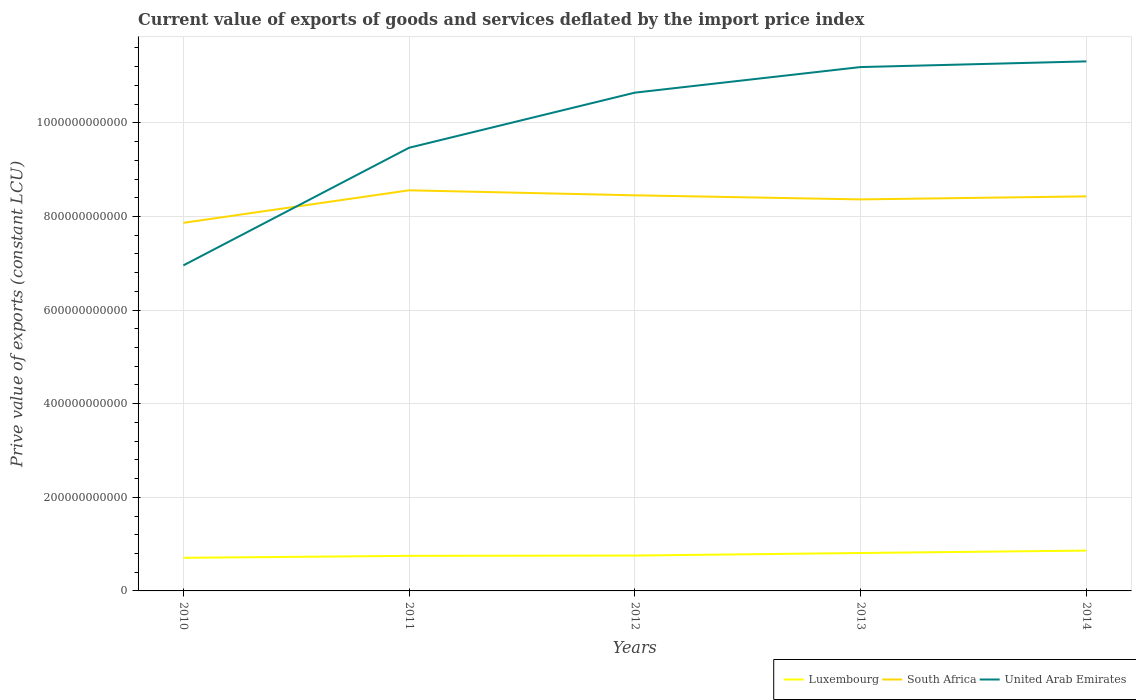How many different coloured lines are there?
Give a very brief answer. 3. Across all years, what is the maximum prive value of exports in United Arab Emirates?
Offer a terse response. 6.95e+11. In which year was the prive value of exports in Luxembourg maximum?
Keep it short and to the point. 2010. What is the total prive value of exports in Luxembourg in the graph?
Offer a very short reply. -4.20e+09. What is the difference between the highest and the second highest prive value of exports in Luxembourg?
Offer a very short reply. 1.54e+1. What is the difference between the highest and the lowest prive value of exports in South Africa?
Keep it short and to the point. 4. Is the prive value of exports in United Arab Emirates strictly greater than the prive value of exports in South Africa over the years?
Give a very brief answer. No. How many lines are there?
Your answer should be compact. 3. How many years are there in the graph?
Give a very brief answer. 5. What is the difference between two consecutive major ticks on the Y-axis?
Offer a terse response. 2.00e+11. Are the values on the major ticks of Y-axis written in scientific E-notation?
Give a very brief answer. No. Where does the legend appear in the graph?
Your response must be concise. Bottom right. How many legend labels are there?
Provide a succinct answer. 3. How are the legend labels stacked?
Ensure brevity in your answer.  Horizontal. What is the title of the graph?
Provide a short and direct response. Current value of exports of goods and services deflated by the import price index. Does "Paraguay" appear as one of the legend labels in the graph?
Your answer should be very brief. No. What is the label or title of the X-axis?
Offer a very short reply. Years. What is the label or title of the Y-axis?
Your answer should be very brief. Prive value of exports (constant LCU). What is the Prive value of exports (constant LCU) of Luxembourg in 2010?
Ensure brevity in your answer.  7.08e+1. What is the Prive value of exports (constant LCU) of South Africa in 2010?
Keep it short and to the point. 7.86e+11. What is the Prive value of exports (constant LCU) in United Arab Emirates in 2010?
Make the answer very short. 6.95e+11. What is the Prive value of exports (constant LCU) of Luxembourg in 2011?
Give a very brief answer. 7.50e+1. What is the Prive value of exports (constant LCU) in South Africa in 2011?
Your response must be concise. 8.56e+11. What is the Prive value of exports (constant LCU) in United Arab Emirates in 2011?
Make the answer very short. 9.47e+11. What is the Prive value of exports (constant LCU) of Luxembourg in 2012?
Ensure brevity in your answer.  7.56e+1. What is the Prive value of exports (constant LCU) in South Africa in 2012?
Make the answer very short. 8.45e+11. What is the Prive value of exports (constant LCU) in United Arab Emirates in 2012?
Your response must be concise. 1.06e+12. What is the Prive value of exports (constant LCU) of Luxembourg in 2013?
Your answer should be very brief. 8.10e+1. What is the Prive value of exports (constant LCU) of South Africa in 2013?
Keep it short and to the point. 8.36e+11. What is the Prive value of exports (constant LCU) in United Arab Emirates in 2013?
Your response must be concise. 1.12e+12. What is the Prive value of exports (constant LCU) of Luxembourg in 2014?
Your answer should be compact. 8.62e+1. What is the Prive value of exports (constant LCU) of South Africa in 2014?
Provide a succinct answer. 8.43e+11. What is the Prive value of exports (constant LCU) of United Arab Emirates in 2014?
Your response must be concise. 1.13e+12. Across all years, what is the maximum Prive value of exports (constant LCU) of Luxembourg?
Your response must be concise. 8.62e+1. Across all years, what is the maximum Prive value of exports (constant LCU) in South Africa?
Your answer should be compact. 8.56e+11. Across all years, what is the maximum Prive value of exports (constant LCU) in United Arab Emirates?
Provide a succinct answer. 1.13e+12. Across all years, what is the minimum Prive value of exports (constant LCU) of Luxembourg?
Provide a short and direct response. 7.08e+1. Across all years, what is the minimum Prive value of exports (constant LCU) of South Africa?
Provide a succinct answer. 7.86e+11. Across all years, what is the minimum Prive value of exports (constant LCU) in United Arab Emirates?
Give a very brief answer. 6.95e+11. What is the total Prive value of exports (constant LCU) in Luxembourg in the graph?
Give a very brief answer. 3.88e+11. What is the total Prive value of exports (constant LCU) of South Africa in the graph?
Your answer should be compact. 4.17e+12. What is the total Prive value of exports (constant LCU) of United Arab Emirates in the graph?
Ensure brevity in your answer.  4.96e+12. What is the difference between the Prive value of exports (constant LCU) in Luxembourg in 2010 and that in 2011?
Offer a terse response. -4.20e+09. What is the difference between the Prive value of exports (constant LCU) of South Africa in 2010 and that in 2011?
Offer a very short reply. -6.95e+1. What is the difference between the Prive value of exports (constant LCU) in United Arab Emirates in 2010 and that in 2011?
Keep it short and to the point. -2.51e+11. What is the difference between the Prive value of exports (constant LCU) of Luxembourg in 2010 and that in 2012?
Your response must be concise. -4.81e+09. What is the difference between the Prive value of exports (constant LCU) of South Africa in 2010 and that in 2012?
Your answer should be compact. -5.88e+1. What is the difference between the Prive value of exports (constant LCU) of United Arab Emirates in 2010 and that in 2012?
Ensure brevity in your answer.  -3.69e+11. What is the difference between the Prive value of exports (constant LCU) in Luxembourg in 2010 and that in 2013?
Offer a terse response. -1.02e+1. What is the difference between the Prive value of exports (constant LCU) of South Africa in 2010 and that in 2013?
Your answer should be compact. -5.01e+1. What is the difference between the Prive value of exports (constant LCU) of United Arab Emirates in 2010 and that in 2013?
Offer a terse response. -4.24e+11. What is the difference between the Prive value of exports (constant LCU) in Luxembourg in 2010 and that in 2014?
Offer a very short reply. -1.54e+1. What is the difference between the Prive value of exports (constant LCU) of South Africa in 2010 and that in 2014?
Ensure brevity in your answer.  -5.66e+1. What is the difference between the Prive value of exports (constant LCU) in United Arab Emirates in 2010 and that in 2014?
Offer a terse response. -4.36e+11. What is the difference between the Prive value of exports (constant LCU) in Luxembourg in 2011 and that in 2012?
Provide a succinct answer. -6.13e+08. What is the difference between the Prive value of exports (constant LCU) in South Africa in 2011 and that in 2012?
Ensure brevity in your answer.  1.07e+1. What is the difference between the Prive value of exports (constant LCU) in United Arab Emirates in 2011 and that in 2012?
Give a very brief answer. -1.18e+11. What is the difference between the Prive value of exports (constant LCU) in Luxembourg in 2011 and that in 2013?
Give a very brief answer. -6.05e+09. What is the difference between the Prive value of exports (constant LCU) in South Africa in 2011 and that in 2013?
Offer a terse response. 1.94e+1. What is the difference between the Prive value of exports (constant LCU) of United Arab Emirates in 2011 and that in 2013?
Ensure brevity in your answer.  -1.72e+11. What is the difference between the Prive value of exports (constant LCU) in Luxembourg in 2011 and that in 2014?
Offer a very short reply. -1.12e+1. What is the difference between the Prive value of exports (constant LCU) in South Africa in 2011 and that in 2014?
Your response must be concise. 1.30e+1. What is the difference between the Prive value of exports (constant LCU) in United Arab Emirates in 2011 and that in 2014?
Ensure brevity in your answer.  -1.84e+11. What is the difference between the Prive value of exports (constant LCU) in Luxembourg in 2012 and that in 2013?
Ensure brevity in your answer.  -5.44e+09. What is the difference between the Prive value of exports (constant LCU) in South Africa in 2012 and that in 2013?
Ensure brevity in your answer.  8.72e+09. What is the difference between the Prive value of exports (constant LCU) in United Arab Emirates in 2012 and that in 2013?
Offer a very short reply. -5.47e+1. What is the difference between the Prive value of exports (constant LCU) in Luxembourg in 2012 and that in 2014?
Keep it short and to the point. -1.06e+1. What is the difference between the Prive value of exports (constant LCU) in South Africa in 2012 and that in 2014?
Keep it short and to the point. 2.25e+09. What is the difference between the Prive value of exports (constant LCU) in United Arab Emirates in 2012 and that in 2014?
Offer a very short reply. -6.68e+1. What is the difference between the Prive value of exports (constant LCU) in Luxembourg in 2013 and that in 2014?
Your response must be concise. -5.17e+09. What is the difference between the Prive value of exports (constant LCU) in South Africa in 2013 and that in 2014?
Make the answer very short. -6.47e+09. What is the difference between the Prive value of exports (constant LCU) of United Arab Emirates in 2013 and that in 2014?
Ensure brevity in your answer.  -1.21e+1. What is the difference between the Prive value of exports (constant LCU) in Luxembourg in 2010 and the Prive value of exports (constant LCU) in South Africa in 2011?
Your answer should be compact. -7.85e+11. What is the difference between the Prive value of exports (constant LCU) in Luxembourg in 2010 and the Prive value of exports (constant LCU) in United Arab Emirates in 2011?
Your response must be concise. -8.76e+11. What is the difference between the Prive value of exports (constant LCU) of South Africa in 2010 and the Prive value of exports (constant LCU) of United Arab Emirates in 2011?
Your response must be concise. -1.60e+11. What is the difference between the Prive value of exports (constant LCU) in Luxembourg in 2010 and the Prive value of exports (constant LCU) in South Africa in 2012?
Offer a terse response. -7.74e+11. What is the difference between the Prive value of exports (constant LCU) of Luxembourg in 2010 and the Prive value of exports (constant LCU) of United Arab Emirates in 2012?
Provide a succinct answer. -9.94e+11. What is the difference between the Prive value of exports (constant LCU) of South Africa in 2010 and the Prive value of exports (constant LCU) of United Arab Emirates in 2012?
Provide a short and direct response. -2.78e+11. What is the difference between the Prive value of exports (constant LCU) of Luxembourg in 2010 and the Prive value of exports (constant LCU) of South Africa in 2013?
Provide a succinct answer. -7.66e+11. What is the difference between the Prive value of exports (constant LCU) of Luxembourg in 2010 and the Prive value of exports (constant LCU) of United Arab Emirates in 2013?
Your answer should be compact. -1.05e+12. What is the difference between the Prive value of exports (constant LCU) of South Africa in 2010 and the Prive value of exports (constant LCU) of United Arab Emirates in 2013?
Your answer should be compact. -3.33e+11. What is the difference between the Prive value of exports (constant LCU) in Luxembourg in 2010 and the Prive value of exports (constant LCU) in South Africa in 2014?
Keep it short and to the point. -7.72e+11. What is the difference between the Prive value of exports (constant LCU) of Luxembourg in 2010 and the Prive value of exports (constant LCU) of United Arab Emirates in 2014?
Make the answer very short. -1.06e+12. What is the difference between the Prive value of exports (constant LCU) of South Africa in 2010 and the Prive value of exports (constant LCU) of United Arab Emirates in 2014?
Keep it short and to the point. -3.45e+11. What is the difference between the Prive value of exports (constant LCU) in Luxembourg in 2011 and the Prive value of exports (constant LCU) in South Africa in 2012?
Give a very brief answer. -7.70e+11. What is the difference between the Prive value of exports (constant LCU) in Luxembourg in 2011 and the Prive value of exports (constant LCU) in United Arab Emirates in 2012?
Your answer should be very brief. -9.90e+11. What is the difference between the Prive value of exports (constant LCU) in South Africa in 2011 and the Prive value of exports (constant LCU) in United Arab Emirates in 2012?
Make the answer very short. -2.09e+11. What is the difference between the Prive value of exports (constant LCU) of Luxembourg in 2011 and the Prive value of exports (constant LCU) of South Africa in 2013?
Ensure brevity in your answer.  -7.61e+11. What is the difference between the Prive value of exports (constant LCU) in Luxembourg in 2011 and the Prive value of exports (constant LCU) in United Arab Emirates in 2013?
Provide a succinct answer. -1.04e+12. What is the difference between the Prive value of exports (constant LCU) of South Africa in 2011 and the Prive value of exports (constant LCU) of United Arab Emirates in 2013?
Provide a succinct answer. -2.63e+11. What is the difference between the Prive value of exports (constant LCU) in Luxembourg in 2011 and the Prive value of exports (constant LCU) in South Africa in 2014?
Ensure brevity in your answer.  -7.68e+11. What is the difference between the Prive value of exports (constant LCU) of Luxembourg in 2011 and the Prive value of exports (constant LCU) of United Arab Emirates in 2014?
Your response must be concise. -1.06e+12. What is the difference between the Prive value of exports (constant LCU) in South Africa in 2011 and the Prive value of exports (constant LCU) in United Arab Emirates in 2014?
Ensure brevity in your answer.  -2.75e+11. What is the difference between the Prive value of exports (constant LCU) in Luxembourg in 2012 and the Prive value of exports (constant LCU) in South Africa in 2013?
Your answer should be compact. -7.61e+11. What is the difference between the Prive value of exports (constant LCU) of Luxembourg in 2012 and the Prive value of exports (constant LCU) of United Arab Emirates in 2013?
Offer a terse response. -1.04e+12. What is the difference between the Prive value of exports (constant LCU) of South Africa in 2012 and the Prive value of exports (constant LCU) of United Arab Emirates in 2013?
Your answer should be compact. -2.74e+11. What is the difference between the Prive value of exports (constant LCU) of Luxembourg in 2012 and the Prive value of exports (constant LCU) of South Africa in 2014?
Your response must be concise. -7.67e+11. What is the difference between the Prive value of exports (constant LCU) of Luxembourg in 2012 and the Prive value of exports (constant LCU) of United Arab Emirates in 2014?
Provide a short and direct response. -1.06e+12. What is the difference between the Prive value of exports (constant LCU) in South Africa in 2012 and the Prive value of exports (constant LCU) in United Arab Emirates in 2014?
Provide a short and direct response. -2.86e+11. What is the difference between the Prive value of exports (constant LCU) in Luxembourg in 2013 and the Prive value of exports (constant LCU) in South Africa in 2014?
Make the answer very short. -7.62e+11. What is the difference between the Prive value of exports (constant LCU) of Luxembourg in 2013 and the Prive value of exports (constant LCU) of United Arab Emirates in 2014?
Give a very brief answer. -1.05e+12. What is the difference between the Prive value of exports (constant LCU) of South Africa in 2013 and the Prive value of exports (constant LCU) of United Arab Emirates in 2014?
Your answer should be very brief. -2.95e+11. What is the average Prive value of exports (constant LCU) in Luxembourg per year?
Offer a very short reply. 7.77e+1. What is the average Prive value of exports (constant LCU) of South Africa per year?
Offer a terse response. 8.33e+11. What is the average Prive value of exports (constant LCU) in United Arab Emirates per year?
Offer a very short reply. 9.91e+11. In the year 2010, what is the difference between the Prive value of exports (constant LCU) of Luxembourg and Prive value of exports (constant LCU) of South Africa?
Offer a terse response. -7.16e+11. In the year 2010, what is the difference between the Prive value of exports (constant LCU) of Luxembourg and Prive value of exports (constant LCU) of United Arab Emirates?
Keep it short and to the point. -6.25e+11. In the year 2010, what is the difference between the Prive value of exports (constant LCU) in South Africa and Prive value of exports (constant LCU) in United Arab Emirates?
Your answer should be compact. 9.09e+1. In the year 2011, what is the difference between the Prive value of exports (constant LCU) in Luxembourg and Prive value of exports (constant LCU) in South Africa?
Ensure brevity in your answer.  -7.81e+11. In the year 2011, what is the difference between the Prive value of exports (constant LCU) of Luxembourg and Prive value of exports (constant LCU) of United Arab Emirates?
Ensure brevity in your answer.  -8.72e+11. In the year 2011, what is the difference between the Prive value of exports (constant LCU) in South Africa and Prive value of exports (constant LCU) in United Arab Emirates?
Offer a terse response. -9.09e+1. In the year 2012, what is the difference between the Prive value of exports (constant LCU) in Luxembourg and Prive value of exports (constant LCU) in South Africa?
Provide a succinct answer. -7.70e+11. In the year 2012, what is the difference between the Prive value of exports (constant LCU) in Luxembourg and Prive value of exports (constant LCU) in United Arab Emirates?
Make the answer very short. -9.89e+11. In the year 2012, what is the difference between the Prive value of exports (constant LCU) in South Africa and Prive value of exports (constant LCU) in United Arab Emirates?
Ensure brevity in your answer.  -2.19e+11. In the year 2013, what is the difference between the Prive value of exports (constant LCU) in Luxembourg and Prive value of exports (constant LCU) in South Africa?
Your response must be concise. -7.55e+11. In the year 2013, what is the difference between the Prive value of exports (constant LCU) in Luxembourg and Prive value of exports (constant LCU) in United Arab Emirates?
Keep it short and to the point. -1.04e+12. In the year 2013, what is the difference between the Prive value of exports (constant LCU) in South Africa and Prive value of exports (constant LCU) in United Arab Emirates?
Ensure brevity in your answer.  -2.83e+11. In the year 2014, what is the difference between the Prive value of exports (constant LCU) of Luxembourg and Prive value of exports (constant LCU) of South Africa?
Your response must be concise. -7.57e+11. In the year 2014, what is the difference between the Prive value of exports (constant LCU) of Luxembourg and Prive value of exports (constant LCU) of United Arab Emirates?
Keep it short and to the point. -1.05e+12. In the year 2014, what is the difference between the Prive value of exports (constant LCU) in South Africa and Prive value of exports (constant LCU) in United Arab Emirates?
Keep it short and to the point. -2.88e+11. What is the ratio of the Prive value of exports (constant LCU) of Luxembourg in 2010 to that in 2011?
Keep it short and to the point. 0.94. What is the ratio of the Prive value of exports (constant LCU) in South Africa in 2010 to that in 2011?
Your answer should be very brief. 0.92. What is the ratio of the Prive value of exports (constant LCU) of United Arab Emirates in 2010 to that in 2011?
Offer a terse response. 0.73. What is the ratio of the Prive value of exports (constant LCU) in Luxembourg in 2010 to that in 2012?
Provide a short and direct response. 0.94. What is the ratio of the Prive value of exports (constant LCU) of South Africa in 2010 to that in 2012?
Offer a terse response. 0.93. What is the ratio of the Prive value of exports (constant LCU) of United Arab Emirates in 2010 to that in 2012?
Provide a short and direct response. 0.65. What is the ratio of the Prive value of exports (constant LCU) of Luxembourg in 2010 to that in 2013?
Your answer should be compact. 0.87. What is the ratio of the Prive value of exports (constant LCU) in South Africa in 2010 to that in 2013?
Keep it short and to the point. 0.94. What is the ratio of the Prive value of exports (constant LCU) of United Arab Emirates in 2010 to that in 2013?
Keep it short and to the point. 0.62. What is the ratio of the Prive value of exports (constant LCU) in Luxembourg in 2010 to that in 2014?
Keep it short and to the point. 0.82. What is the ratio of the Prive value of exports (constant LCU) in South Africa in 2010 to that in 2014?
Your response must be concise. 0.93. What is the ratio of the Prive value of exports (constant LCU) of United Arab Emirates in 2010 to that in 2014?
Provide a succinct answer. 0.61. What is the ratio of the Prive value of exports (constant LCU) in South Africa in 2011 to that in 2012?
Provide a succinct answer. 1.01. What is the ratio of the Prive value of exports (constant LCU) in United Arab Emirates in 2011 to that in 2012?
Keep it short and to the point. 0.89. What is the ratio of the Prive value of exports (constant LCU) in Luxembourg in 2011 to that in 2013?
Your response must be concise. 0.93. What is the ratio of the Prive value of exports (constant LCU) in South Africa in 2011 to that in 2013?
Your answer should be compact. 1.02. What is the ratio of the Prive value of exports (constant LCU) in United Arab Emirates in 2011 to that in 2013?
Your response must be concise. 0.85. What is the ratio of the Prive value of exports (constant LCU) in Luxembourg in 2011 to that in 2014?
Offer a terse response. 0.87. What is the ratio of the Prive value of exports (constant LCU) in South Africa in 2011 to that in 2014?
Your answer should be very brief. 1.02. What is the ratio of the Prive value of exports (constant LCU) in United Arab Emirates in 2011 to that in 2014?
Give a very brief answer. 0.84. What is the ratio of the Prive value of exports (constant LCU) in Luxembourg in 2012 to that in 2013?
Provide a short and direct response. 0.93. What is the ratio of the Prive value of exports (constant LCU) in South Africa in 2012 to that in 2013?
Provide a short and direct response. 1.01. What is the ratio of the Prive value of exports (constant LCU) of United Arab Emirates in 2012 to that in 2013?
Provide a short and direct response. 0.95. What is the ratio of the Prive value of exports (constant LCU) of Luxembourg in 2012 to that in 2014?
Make the answer very short. 0.88. What is the ratio of the Prive value of exports (constant LCU) of South Africa in 2012 to that in 2014?
Ensure brevity in your answer.  1. What is the ratio of the Prive value of exports (constant LCU) in United Arab Emirates in 2012 to that in 2014?
Your answer should be very brief. 0.94. What is the ratio of the Prive value of exports (constant LCU) in South Africa in 2013 to that in 2014?
Provide a short and direct response. 0.99. What is the ratio of the Prive value of exports (constant LCU) in United Arab Emirates in 2013 to that in 2014?
Ensure brevity in your answer.  0.99. What is the difference between the highest and the second highest Prive value of exports (constant LCU) in Luxembourg?
Provide a short and direct response. 5.17e+09. What is the difference between the highest and the second highest Prive value of exports (constant LCU) of South Africa?
Offer a terse response. 1.07e+1. What is the difference between the highest and the second highest Prive value of exports (constant LCU) in United Arab Emirates?
Give a very brief answer. 1.21e+1. What is the difference between the highest and the lowest Prive value of exports (constant LCU) of Luxembourg?
Ensure brevity in your answer.  1.54e+1. What is the difference between the highest and the lowest Prive value of exports (constant LCU) in South Africa?
Offer a very short reply. 6.95e+1. What is the difference between the highest and the lowest Prive value of exports (constant LCU) of United Arab Emirates?
Your answer should be very brief. 4.36e+11. 